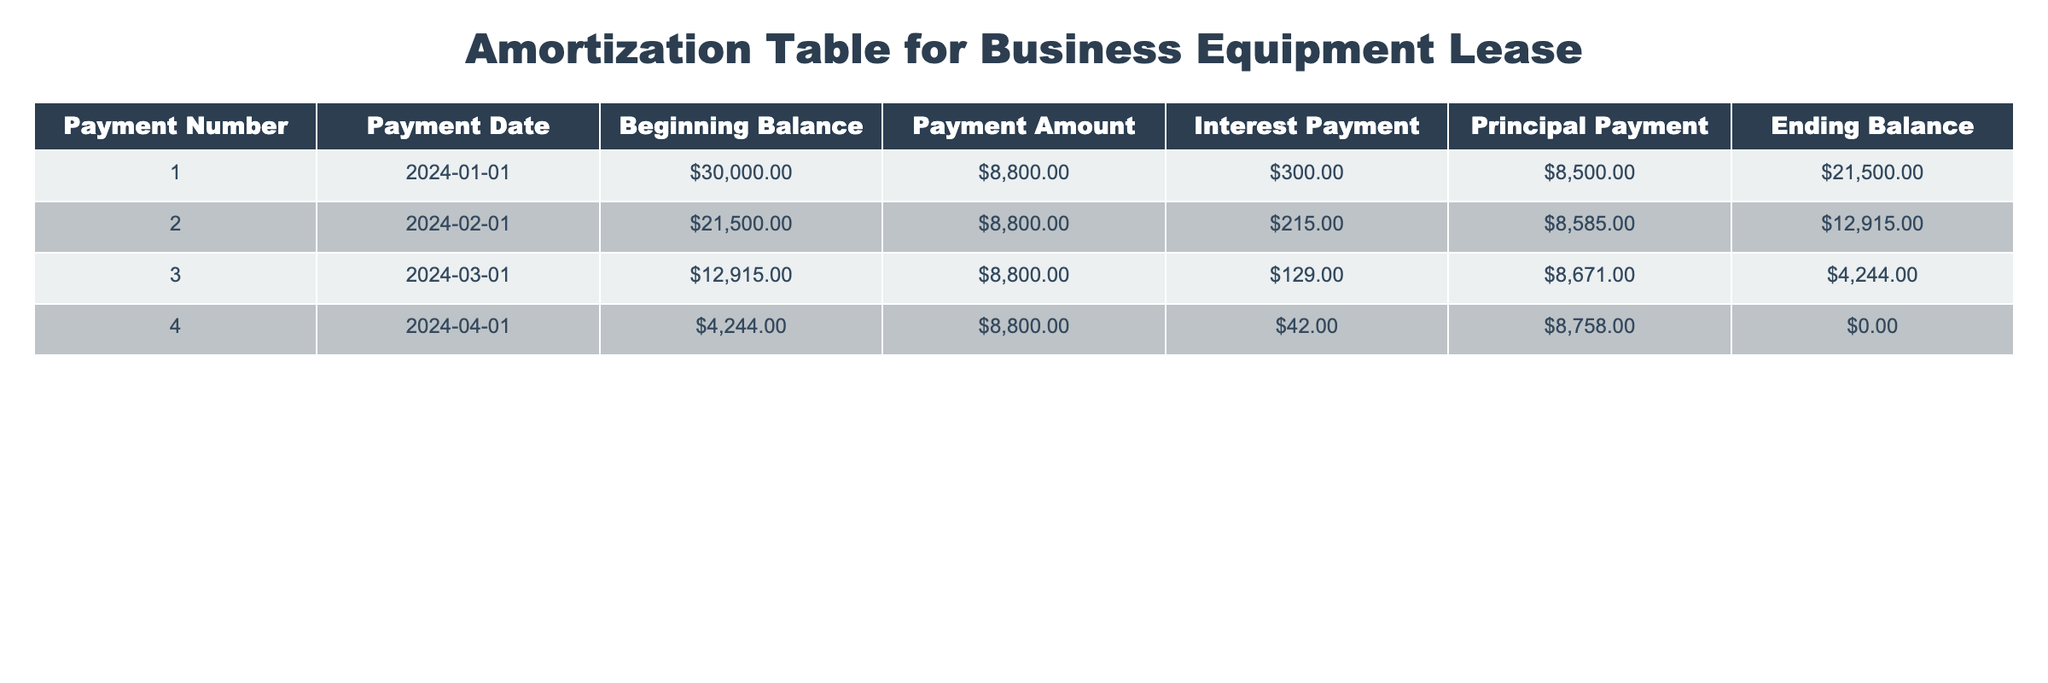What is the payment amount for each installment? The table shows a consistent payment amount across all payment numbers, which is $8,800.
Answer: $8,800 What was the beginning balance after the first payment? After the first payment, the beginning balance is the value from the first row of the table, which shows $30,000.
Answer: $30,000 Did the ending balance ever become negative during the lease term? The ending balance reaches $0 after the fourth payment, and there are no negative values listed in the table.
Answer: No What is the total principal paid over the course of the lease? By summing up the principal payments from each installment (8500 + 8585 + 8671 + 8758), we find the total principal paid is $34,514.
Answer: $34,514 Which payment had the highest interest payment and what was that amount? Reviewing the interest payment column, the highest interest payment occurred in the first payment at $300.
Answer: $300 How much has been paid in total by the end of the second payment? To find total payments made by the end of the second payment, we combine the payment amounts: $8,800 + $8,800 = $17,600.
Answer: $17,600 What is the average principal payment across all payments made? The principal payments from the first four payments are (8500 + 8585 + 8671 + 8758), totaling $34,514, divided by 4 yields an average principal payment of $8,628.50.
Answer: $8,628.50 How many months did it take to fully pay off the lease? The lease was completed after the fourth payment, which was made in April 2024, indicating the lease was fully paid off in four months.
Answer: 4 months What proportion of the first payment was made toward principal? The first payment is $8,800 with $8,500 allocated to principal, making the principal portion approximately 96.59% of the total payment.
Answer: 96.59% 